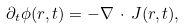Convert formula to latex. <formula><loc_0><loc_0><loc_500><loc_500>\partial _ { t } \phi ( { r } , t ) = - \nabla \, \cdot \, { J } ( { r } , t ) ,</formula> 